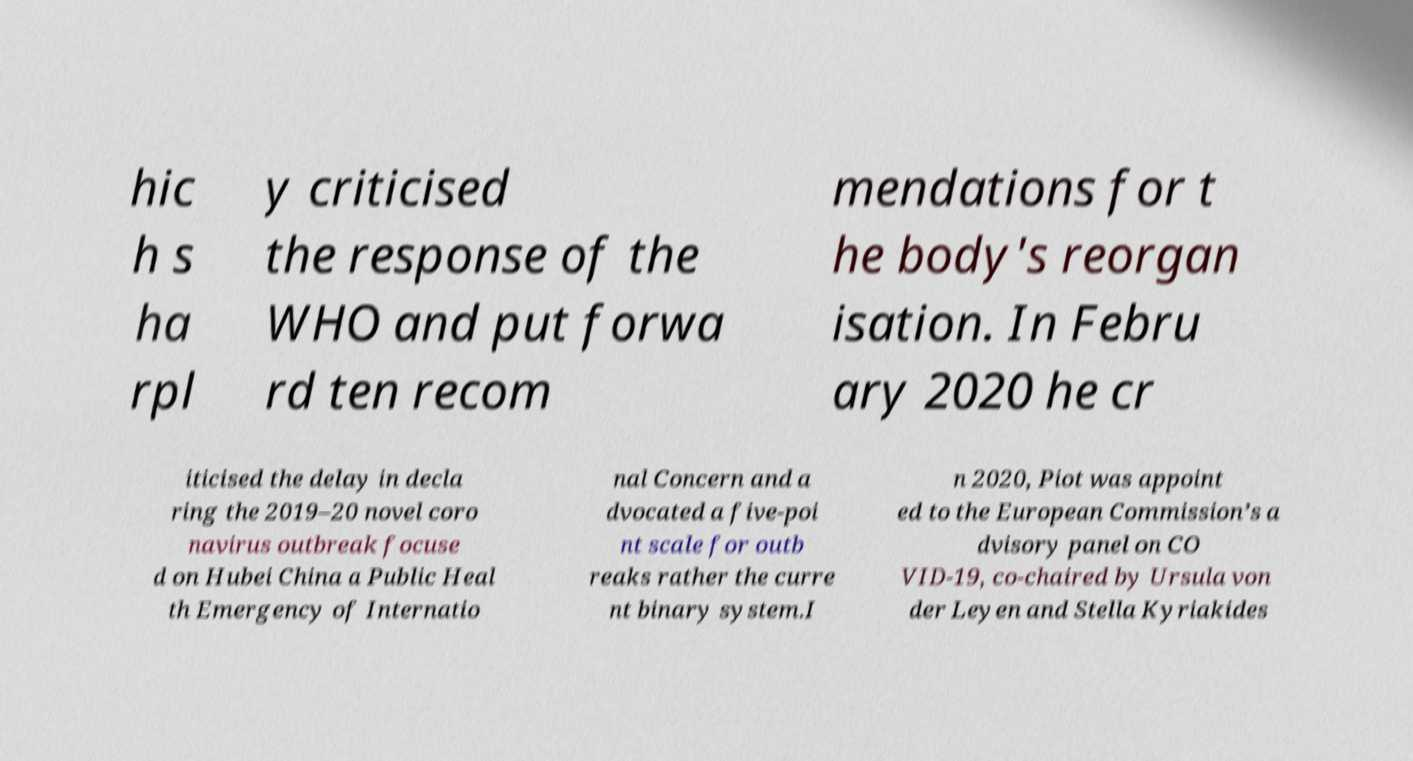There's text embedded in this image that I need extracted. Can you transcribe it verbatim? hic h s ha rpl y criticised the response of the WHO and put forwa rd ten recom mendations for t he body's reorgan isation. In Febru ary 2020 he cr iticised the delay in decla ring the 2019–20 novel coro navirus outbreak focuse d on Hubei China a Public Heal th Emergency of Internatio nal Concern and a dvocated a five-poi nt scale for outb reaks rather the curre nt binary system.I n 2020, Piot was appoint ed to the European Commission’s a dvisory panel on CO VID-19, co-chaired by Ursula von der Leyen and Stella Kyriakides 